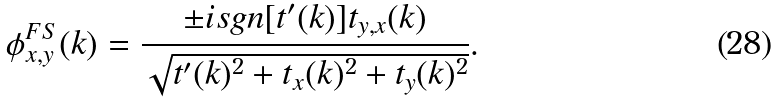Convert formula to latex. <formula><loc_0><loc_0><loc_500><loc_500>\phi _ { x , y } ^ { F S } ( k ) = \frac { \pm i s g n [ t ^ { \prime } ( k ) ] t _ { y , x } ( k ) } { \sqrt { t ^ { \prime } ( k ) ^ { 2 } + t _ { x } ( k ) ^ { 2 } + t _ { y } ( k ) ^ { 2 } } } .</formula> 